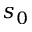<formula> <loc_0><loc_0><loc_500><loc_500>s _ { 0 }</formula> 